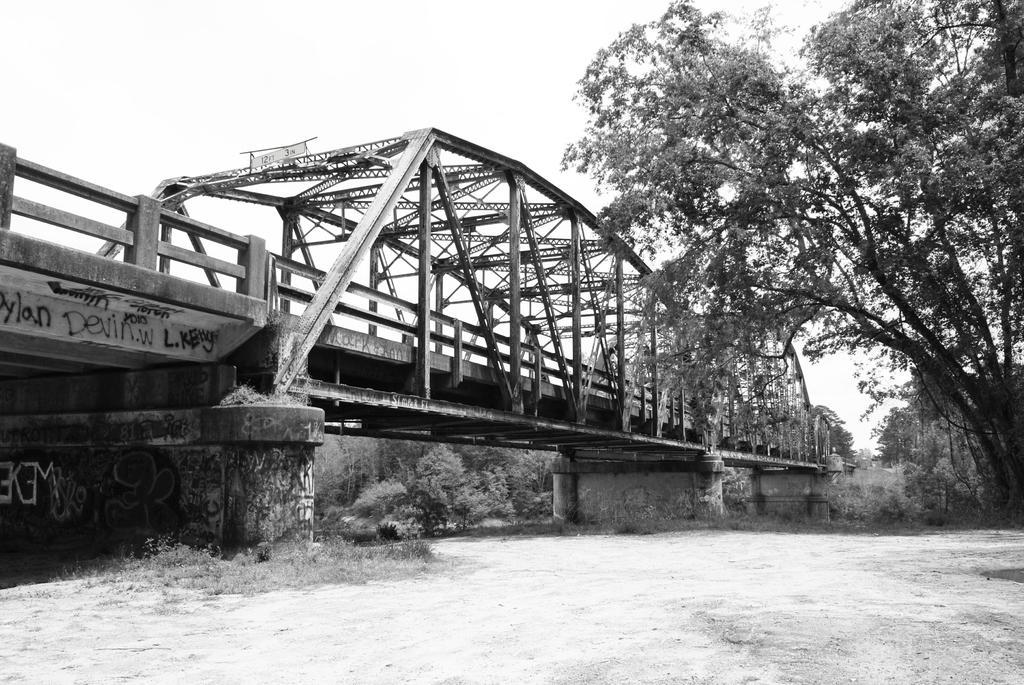Could you give a brief overview of what you see in this image? This is a black and white image, in this image there is a land and a tree, in the background there is a bridge and trees. 